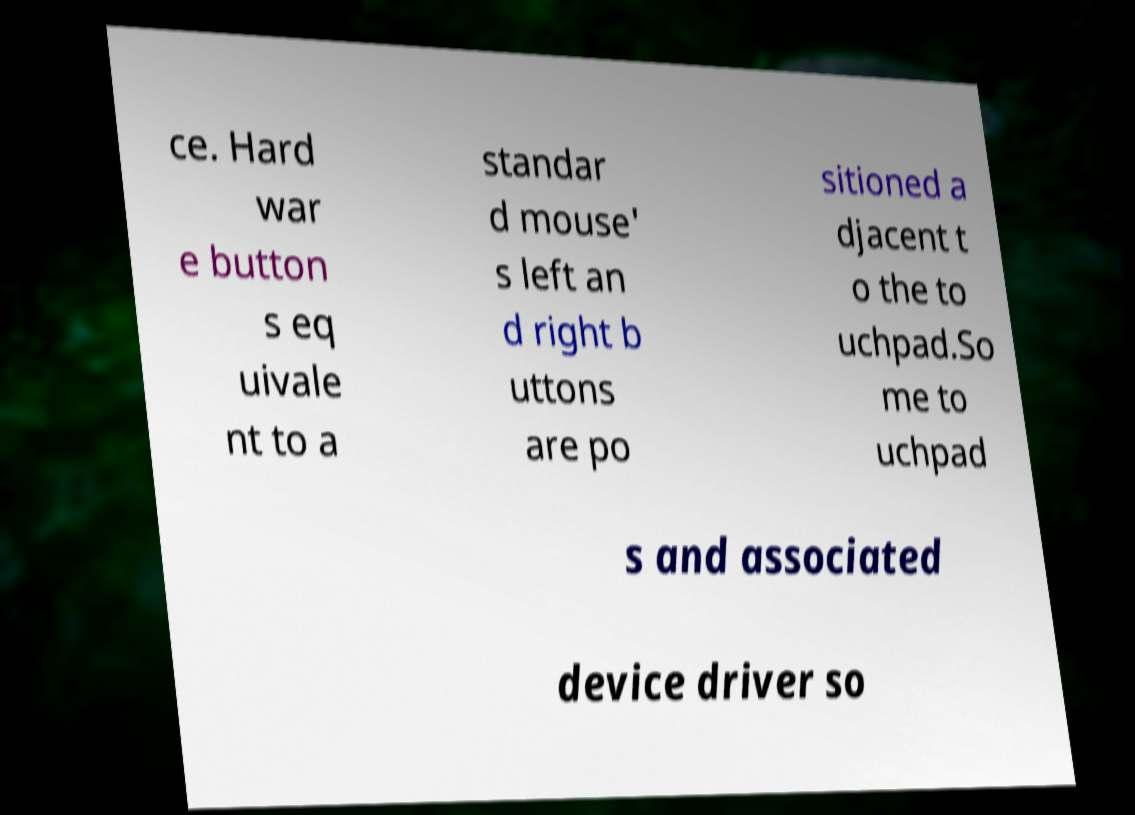There's text embedded in this image that I need extracted. Can you transcribe it verbatim? ce. Hard war e button s eq uivale nt to a standar d mouse' s left an d right b uttons are po sitioned a djacent t o the to uchpad.So me to uchpad s and associated device driver so 